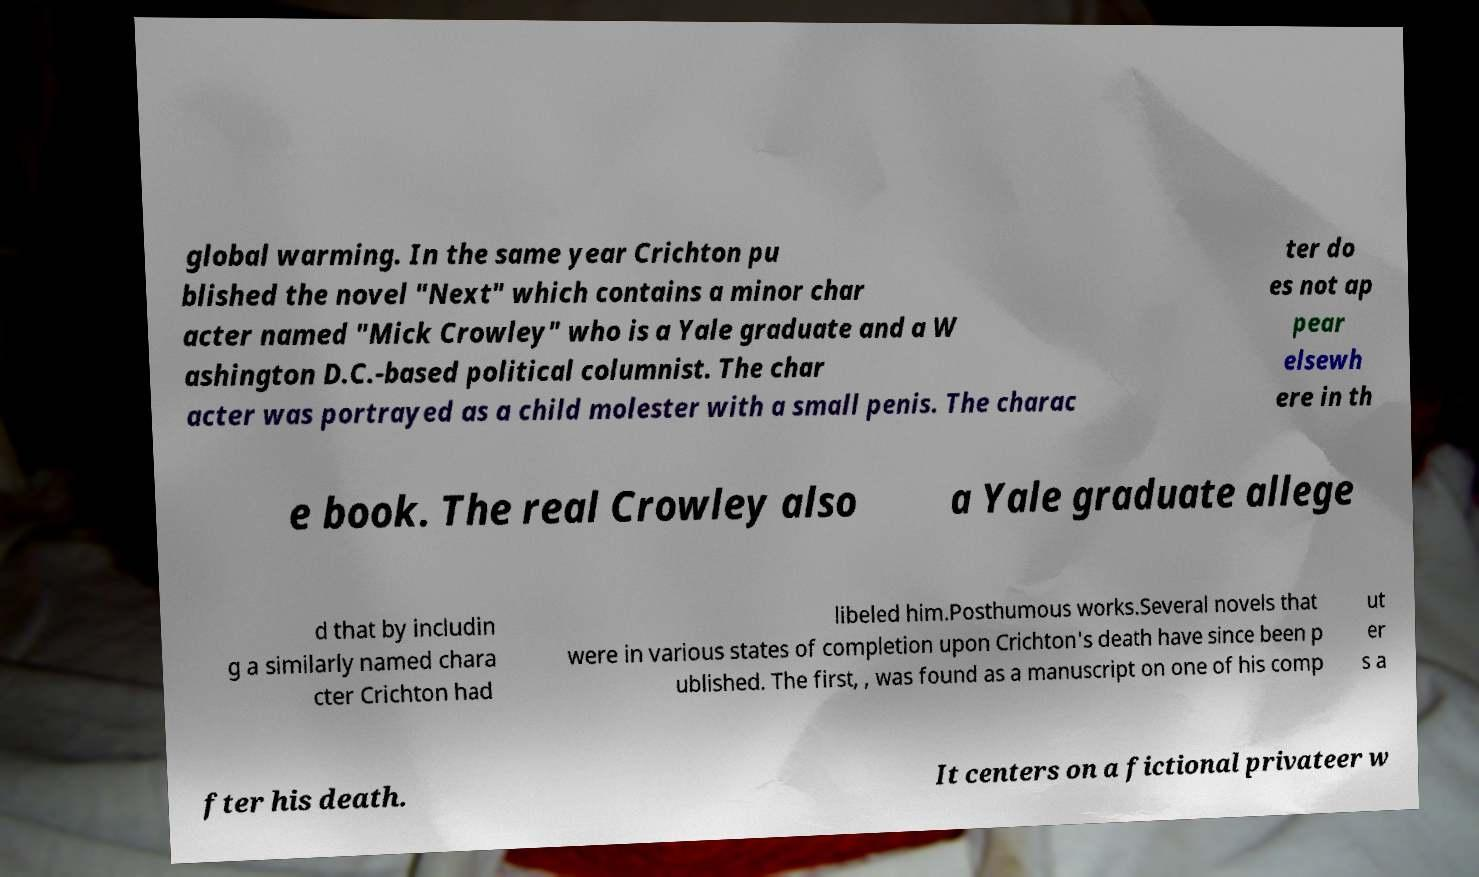I need the written content from this picture converted into text. Can you do that? global warming. In the same year Crichton pu blished the novel "Next" which contains a minor char acter named "Mick Crowley" who is a Yale graduate and a W ashington D.C.-based political columnist. The char acter was portrayed as a child molester with a small penis. The charac ter do es not ap pear elsewh ere in th e book. The real Crowley also a Yale graduate allege d that by includin g a similarly named chara cter Crichton had libeled him.Posthumous works.Several novels that were in various states of completion upon Crichton's death have since been p ublished. The first, , was found as a manuscript on one of his comp ut er s a fter his death. It centers on a fictional privateer w 